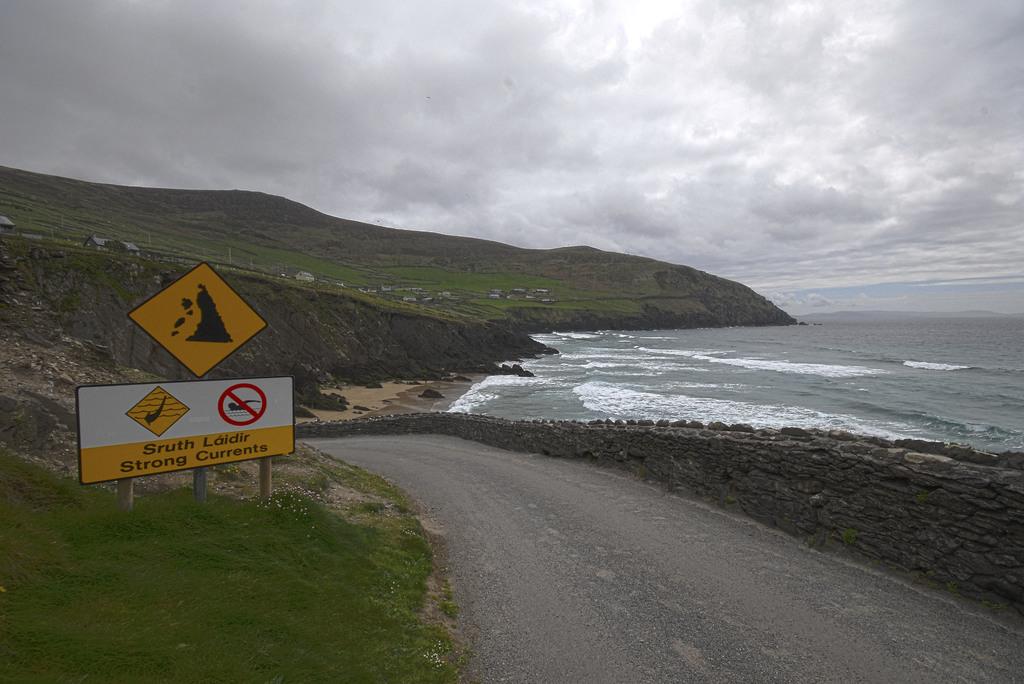What is this sign warning people of?
Give a very brief answer. Strong currents. 